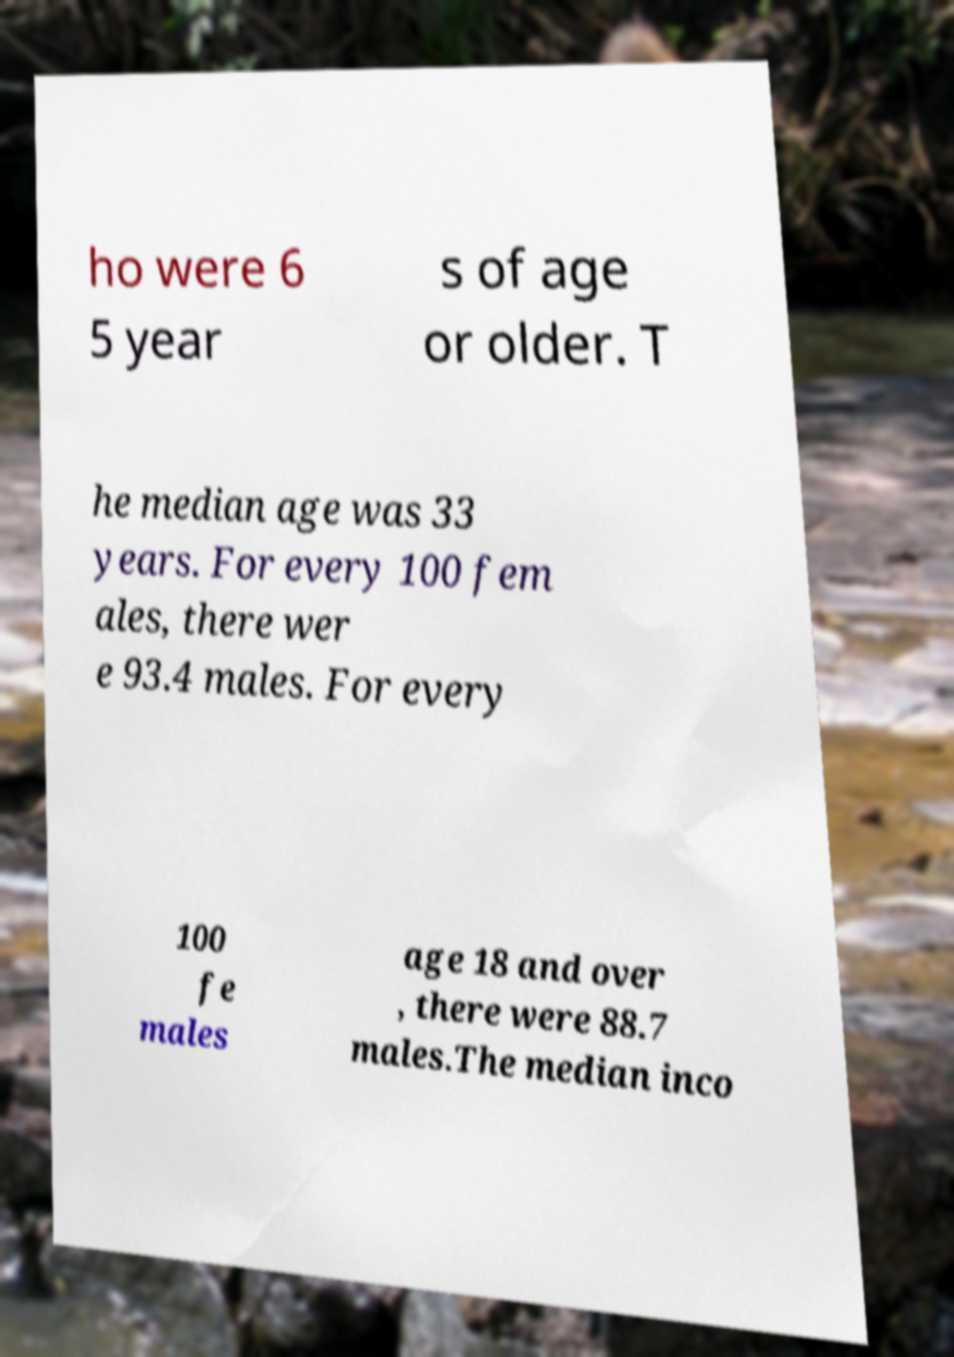Could you assist in decoding the text presented in this image and type it out clearly? ho were 6 5 year s of age or older. T he median age was 33 years. For every 100 fem ales, there wer e 93.4 males. For every 100 fe males age 18 and over , there were 88.7 males.The median inco 